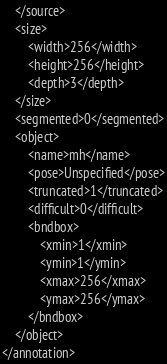Convert code to text. <code><loc_0><loc_0><loc_500><loc_500><_XML_>	</source>
	<size>
		<width>256</width>
		<height>256</height>
		<depth>3</depth>
	</size>
	<segmented>0</segmented>
	<object>
		<name>mh</name>
		<pose>Unspecified</pose>
		<truncated>1</truncated>
		<difficult>0</difficult>
		<bndbox>
			<xmin>1</xmin>
			<ymin>1</ymin>
			<xmax>256</xmax>
			<ymax>256</ymax>
		</bndbox>
	</object>
</annotation>
</code> 